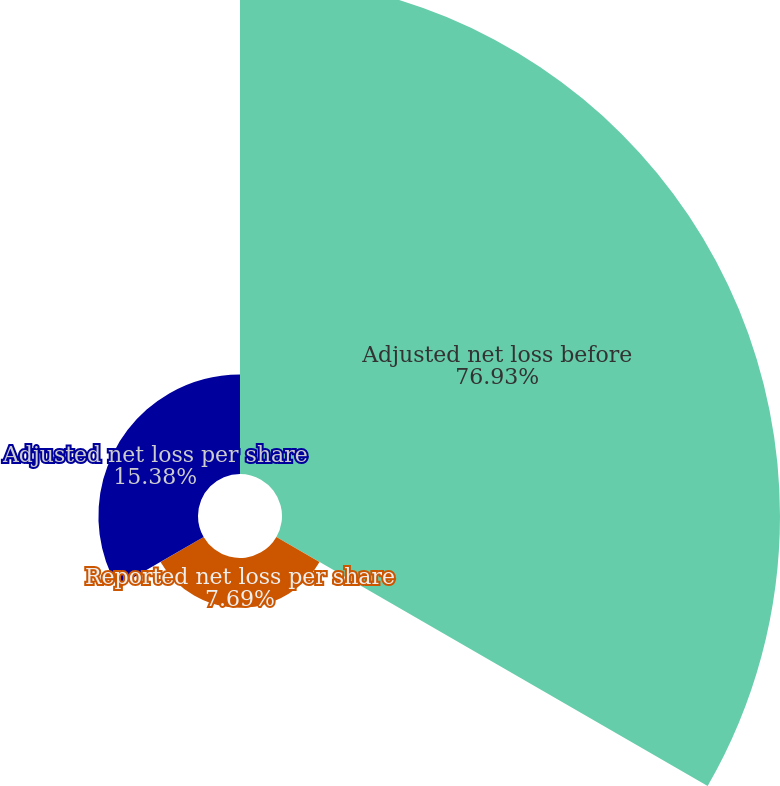<chart> <loc_0><loc_0><loc_500><loc_500><pie_chart><fcel>Adjusted net loss before<fcel>Reported net loss per share<fcel>Adjusted net loss per share<nl><fcel>76.92%<fcel>7.69%<fcel>15.38%<nl></chart> 